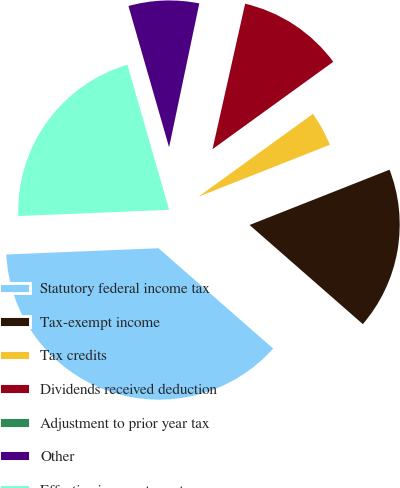Convert chart. <chart><loc_0><loc_0><loc_500><loc_500><pie_chart><fcel>Statutory federal income tax<fcel>Tax-exempt income<fcel>Tax credits<fcel>Dividends received deduction<fcel>Adjustment to prior year tax<fcel>Other<fcel>Effective income tax rate<nl><fcel>37.9%<fcel>17.43%<fcel>3.98%<fcel>11.52%<fcel>0.22%<fcel>7.75%<fcel>21.2%<nl></chart> 